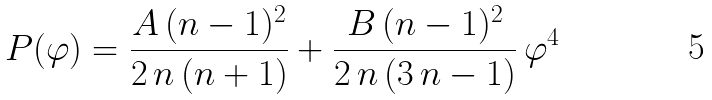<formula> <loc_0><loc_0><loc_500><loc_500>P ( \varphi ) = \frac { A \, ( n - 1 ) ^ { 2 } } { 2 \, n \, ( n + 1 ) } + \frac { B \, ( n - 1 ) ^ { 2 } } { 2 \, n \, ( 3 \, n - 1 ) } \, \varphi ^ { 4 }</formula> 